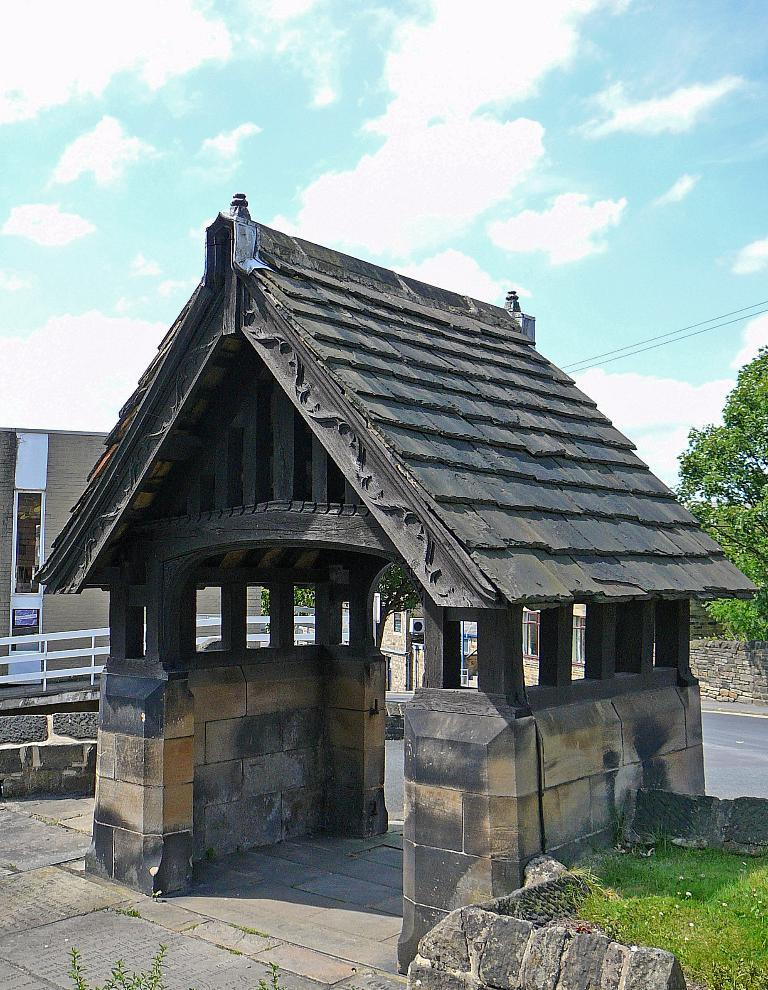What structure is present in the image? There is a shed in the image. Where is the shed located? The shed is placed on the ground. What can be seen in the background of the image? There is a building and a group of trees in the background of the image. How would you describe the sky in the image? The sky is cloudy in the background of the image. What type of music is being played in the shed in the image? There is no indication of music being played in the image, as it only shows a shed placed on the ground with a cloudy sky in the background. 